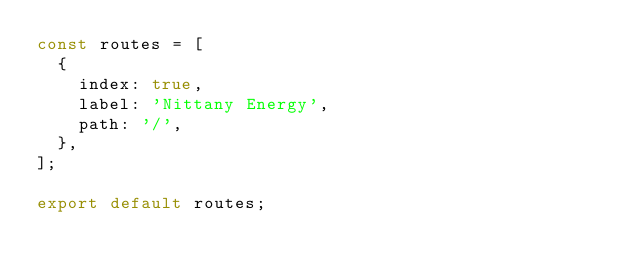Convert code to text. <code><loc_0><loc_0><loc_500><loc_500><_JavaScript_>const routes = [
  {
    index: true,
    label: 'Nittany Energy',
    path: '/',
  },
];

export default routes;
</code> 